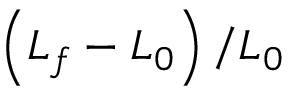<formula> <loc_0><loc_0><loc_500><loc_500>\left ( L _ { f } - L _ { 0 } \right ) / L _ { 0 }</formula> 